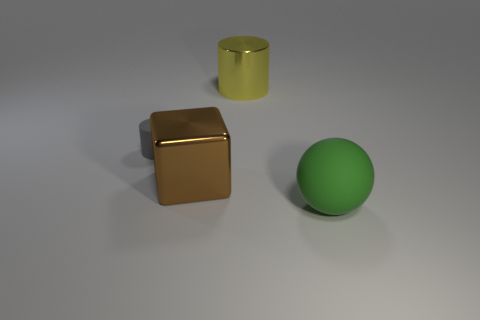There is a shiny object to the left of the shiny cylinder; is its size the same as the green rubber ball?
Make the answer very short. Yes. What number of small objects are purple shiny cylinders or yellow objects?
Make the answer very short. 0. How many small rubber objects have the same shape as the big yellow metallic thing?
Your answer should be very brief. 1. There is a big green thing; does it have the same shape as the rubber object behind the green matte ball?
Provide a succinct answer. No. There is a tiny gray cylinder; what number of yellow metallic cylinders are in front of it?
Give a very brief answer. 0. Is there a yellow ball of the same size as the yellow metal object?
Your response must be concise. No. There is a matte thing behind the brown shiny cube; is its shape the same as the yellow shiny object?
Offer a terse response. Yes. What color is the large sphere?
Give a very brief answer. Green. Are there any tiny gray rubber things?
Keep it short and to the point. Yes. The other thing that is the same material as the small gray thing is what size?
Give a very brief answer. Large. 